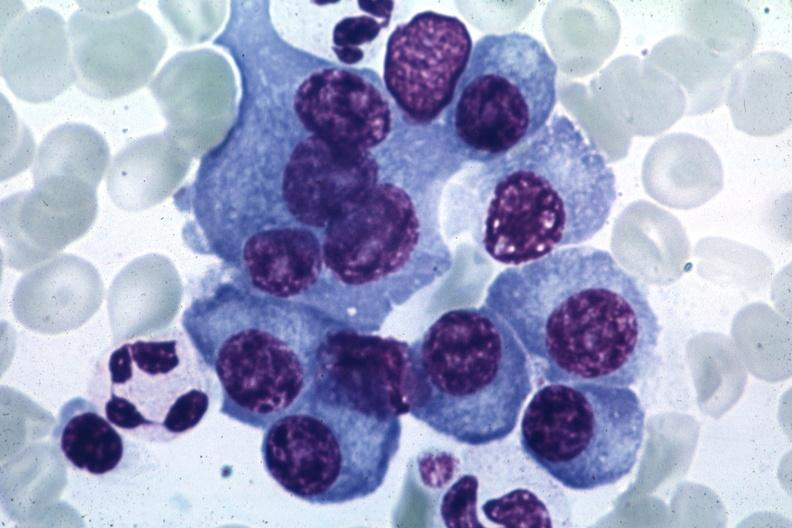s hematologic present?
Answer the question using a single word or phrase. Yes 